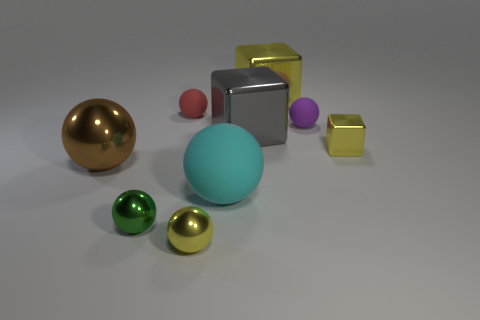Subtract 3 spheres. How many spheres are left? 3 Subtract all yellow balls. How many balls are left? 5 Subtract all yellow balls. How many balls are left? 5 Subtract all gray balls. Subtract all yellow cubes. How many balls are left? 6 Add 1 cyan matte cubes. How many objects exist? 10 Subtract all spheres. How many objects are left? 3 Subtract 0 purple blocks. How many objects are left? 9 Subtract all tiny green shiny balls. Subtract all tiny purple objects. How many objects are left? 7 Add 3 yellow metal balls. How many yellow metal balls are left? 4 Add 7 gray shiny things. How many gray shiny things exist? 8 